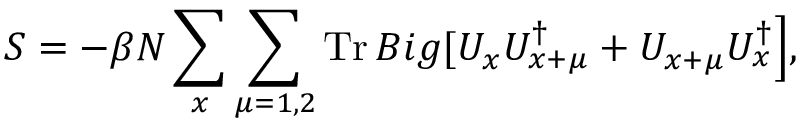<formula> <loc_0><loc_0><loc_500><loc_500>S = - \beta N \sum _ { x } \sum _ { \mu = 1 , 2 } T r \, B i g [ U _ { x } U _ { x + \mu } ^ { \dag } + U _ { x + \mu } U _ { x } ^ { \dag } \Big ] ,</formula> 